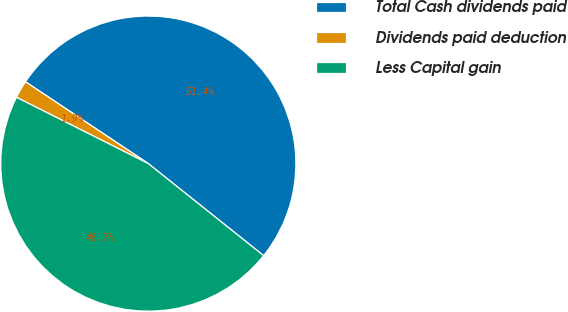Convert chart. <chart><loc_0><loc_0><loc_500><loc_500><pie_chart><fcel>Total Cash dividends paid<fcel>Dividends paid deduction<fcel>Less Capital gain<nl><fcel>51.36%<fcel>1.94%<fcel>46.69%<nl></chart> 